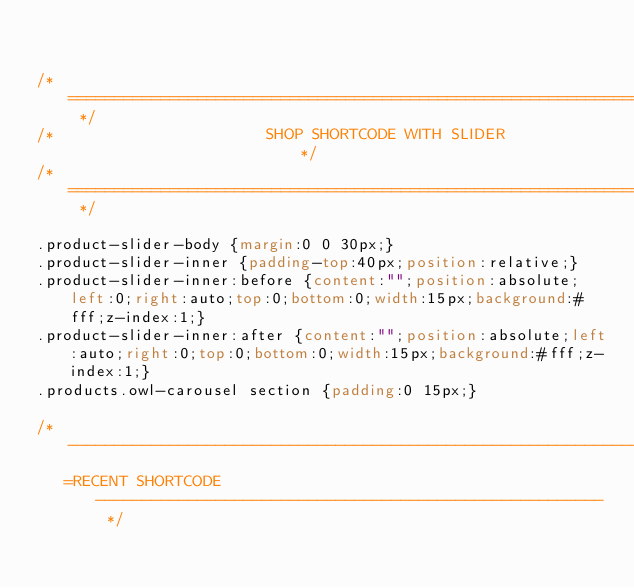<code> <loc_0><loc_0><loc_500><loc_500><_CSS_>

/* ========================================================================= */
/*                       SHOP SHORTCODE WITH SLIDER                          */
/* ========================================================================= */

.product-slider-body {margin:0 0 30px;}
.product-slider-inner {padding-top:40px;position:relative;}
.product-slider-inner:before {content:"";position:absolute;left:0;right:auto;top:0;bottom:0;width:15px;background:#fff;z-index:1;}
.product-slider-inner:after {content:"";position:absolute;left:auto;right:0;top:0;bottom:0;width:15px;background:#fff;z-index:1;}
.products.owl-carousel section {padding:0 15px;}

/* -------------------------------------------------------------------------
   =RECENT SHORTCODE ------------------------------------------------------- */</code> 